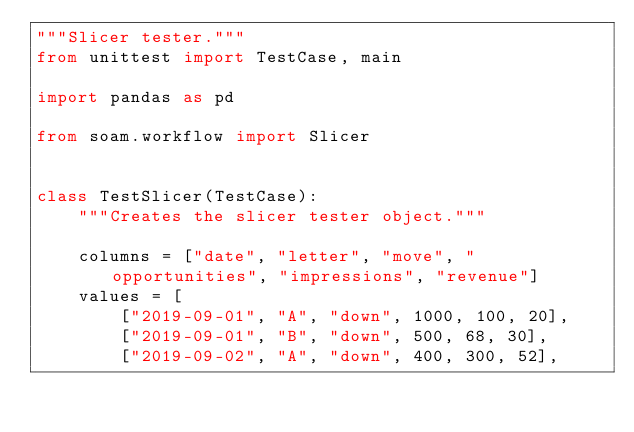<code> <loc_0><loc_0><loc_500><loc_500><_Python_>"""Slicer tester."""
from unittest import TestCase, main

import pandas as pd

from soam.workflow import Slicer


class TestSlicer(TestCase):
    """Creates the slicer tester object."""

    columns = ["date", "letter", "move", "opportunities", "impressions", "revenue"]
    values = [
        ["2019-09-01", "A", "down", 1000, 100, 20],
        ["2019-09-01", "B", "down", 500, 68, 30],
        ["2019-09-02", "A", "down", 400, 300, 52],</code> 